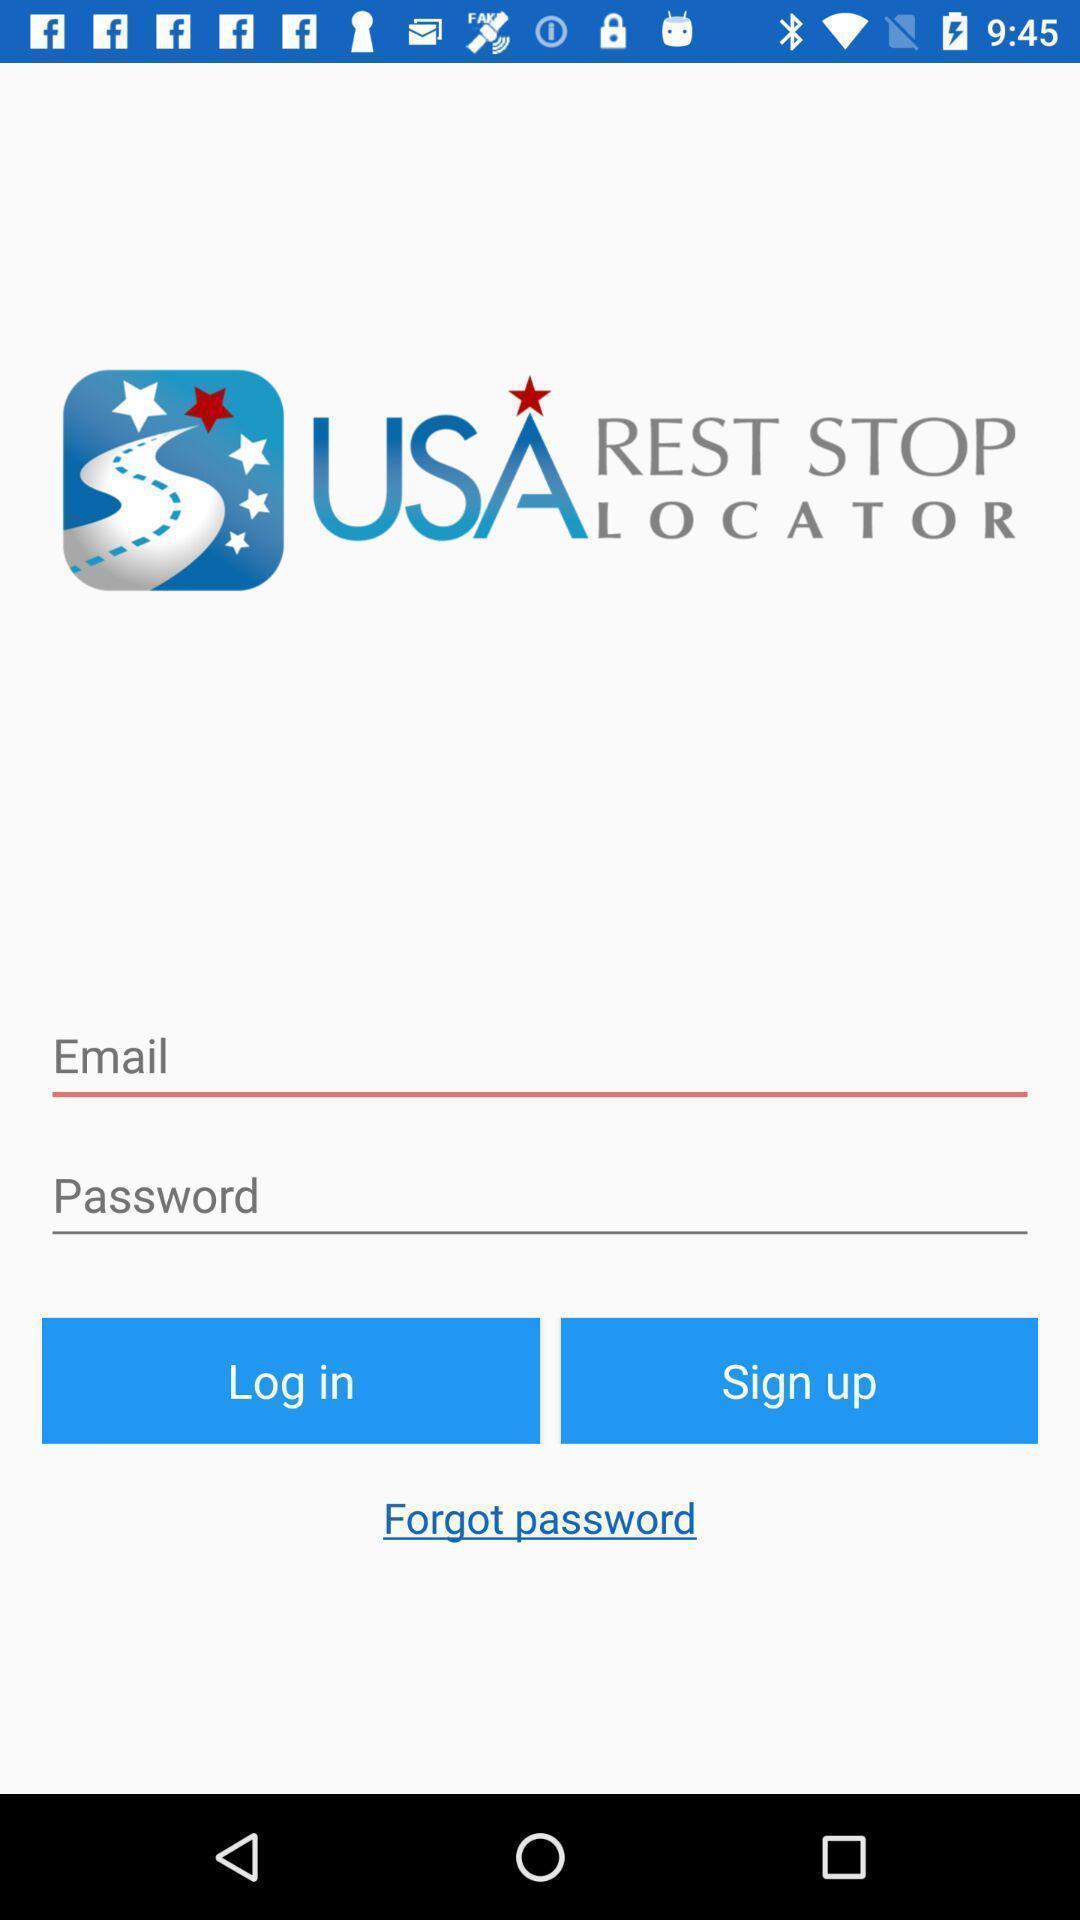What can you discern from this picture? Login page. 